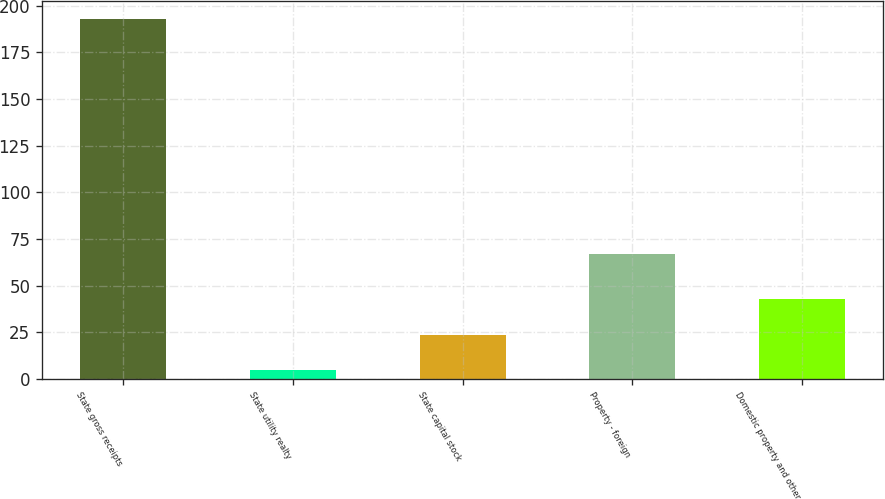Convert chart to OTSL. <chart><loc_0><loc_0><loc_500><loc_500><bar_chart><fcel>State gross receipts<fcel>State utility realty<fcel>State capital stock<fcel>Property - foreign<fcel>Domestic property and other<nl><fcel>193<fcel>5<fcel>23.8<fcel>67<fcel>42.6<nl></chart> 